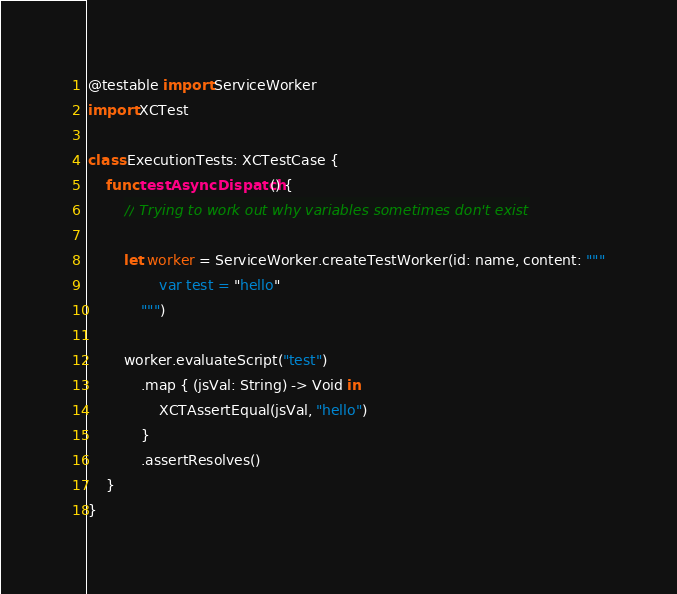<code> <loc_0><loc_0><loc_500><loc_500><_Swift_>@testable import ServiceWorker
import XCTest

class ExecutionTests: XCTestCase {
    func testAsyncDispatch() {
        // Trying to work out why variables sometimes don't exist

        let worker = ServiceWorker.createTestWorker(id: name, content: """
                var test = "hello"
            """)

        worker.evaluateScript("test")
            .map { (jsVal: String) -> Void in
                XCTAssertEqual(jsVal, "hello")
            }
            .assertResolves()
    }
}
</code> 